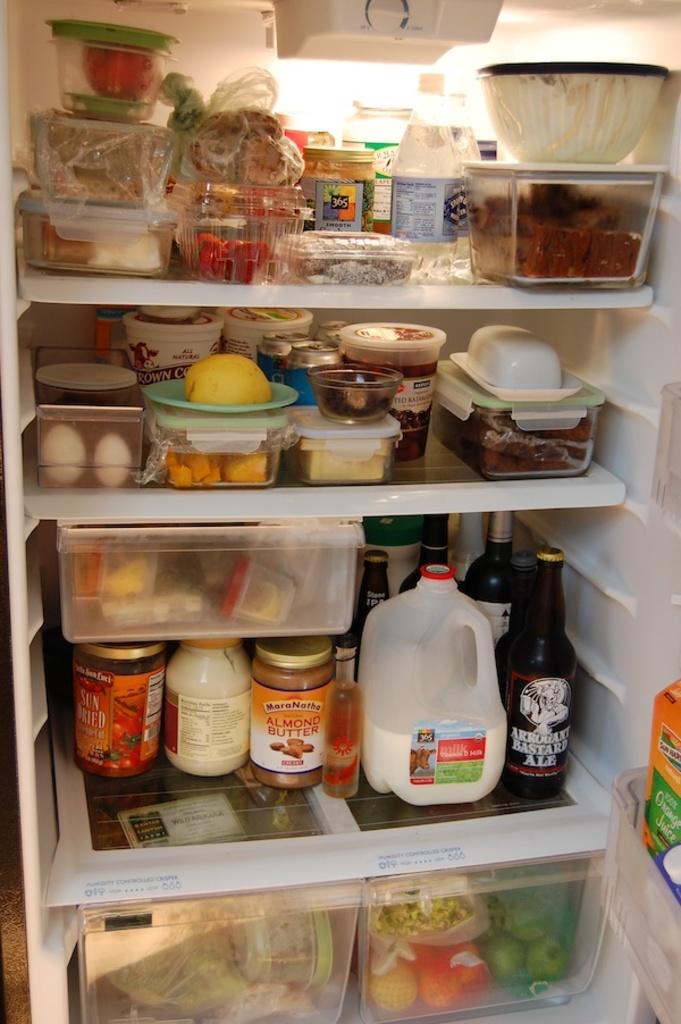What is sitting to the right of the milk?
Your answer should be compact. Ale. 